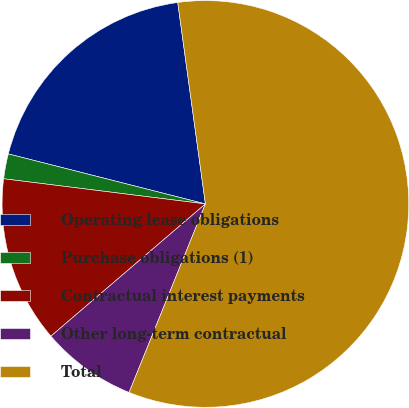<chart> <loc_0><loc_0><loc_500><loc_500><pie_chart><fcel>Operating lease obligations<fcel>Purchase obligations (1)<fcel>Contractual interest payments<fcel>Other long-term contractual<fcel>Total<nl><fcel>18.87%<fcel>1.98%<fcel>13.24%<fcel>7.61%<fcel>58.29%<nl></chart> 